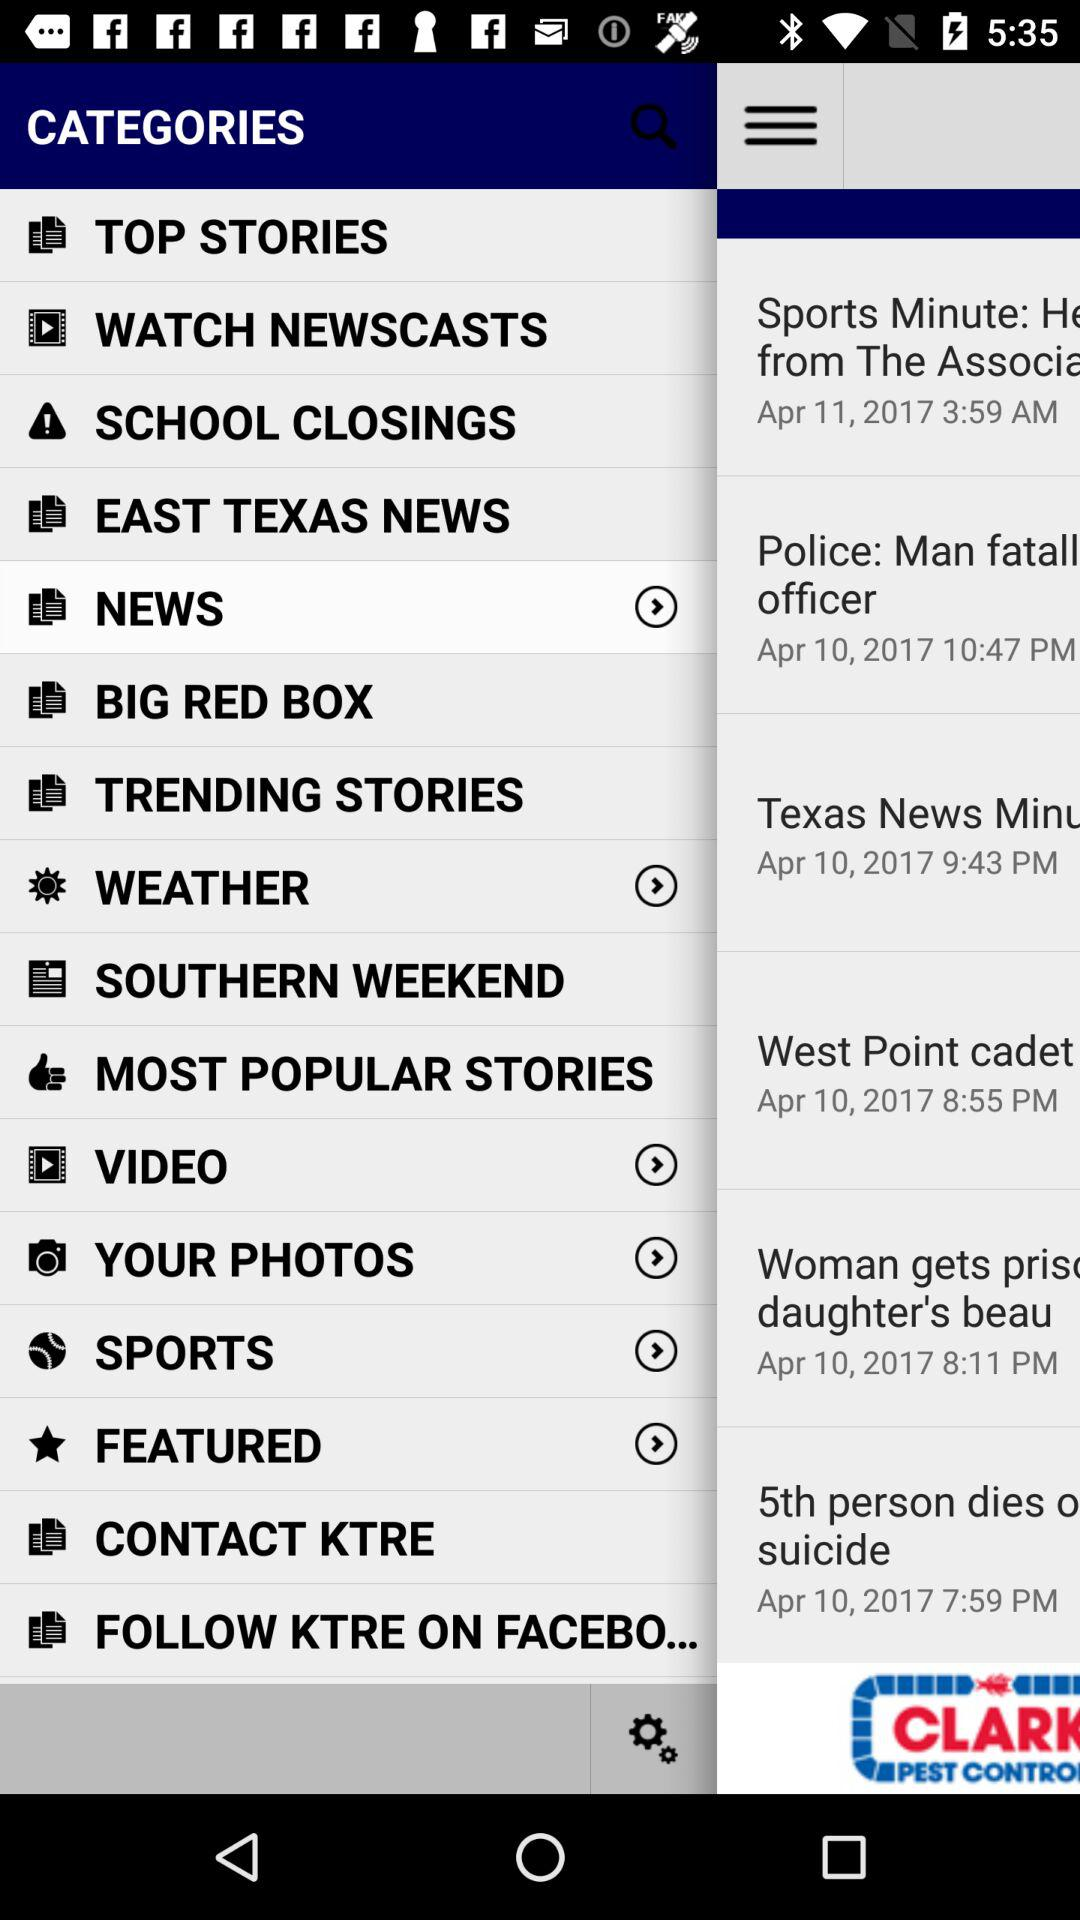What is the contact phone number for KTRE?
When the provided information is insufficient, respond with <no answer>. <no answer> 